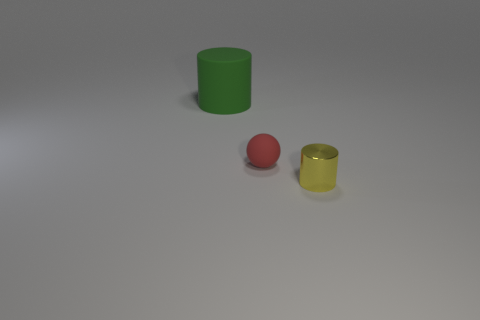Add 3 small metal objects. How many objects exist? 6 Subtract all cylinders. How many objects are left? 1 Add 2 small red balls. How many small red balls are left? 3 Add 2 yellow cylinders. How many yellow cylinders exist? 3 Subtract 0 brown cubes. How many objects are left? 3 Subtract all tiny brown matte objects. Subtract all red matte spheres. How many objects are left? 2 